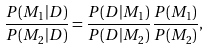Convert formula to latex. <formula><loc_0><loc_0><loc_500><loc_500>\frac { P ( M _ { 1 } | D ) } { P ( M _ { 2 } | D ) } = \frac { P ( D | M _ { 1 } ) } { P ( D | M _ { 2 } ) } \frac { P ( M _ { 1 } ) } { P ( M _ { 2 } ) } ,</formula> 